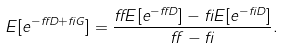Convert formula to latex. <formula><loc_0><loc_0><loc_500><loc_500>E [ e ^ { - \alpha D + \beta G } ] = \frac { \alpha E [ e ^ { - \alpha D } ] - \beta E [ e ^ { - \beta D } ] } { \alpha - \beta } .</formula> 